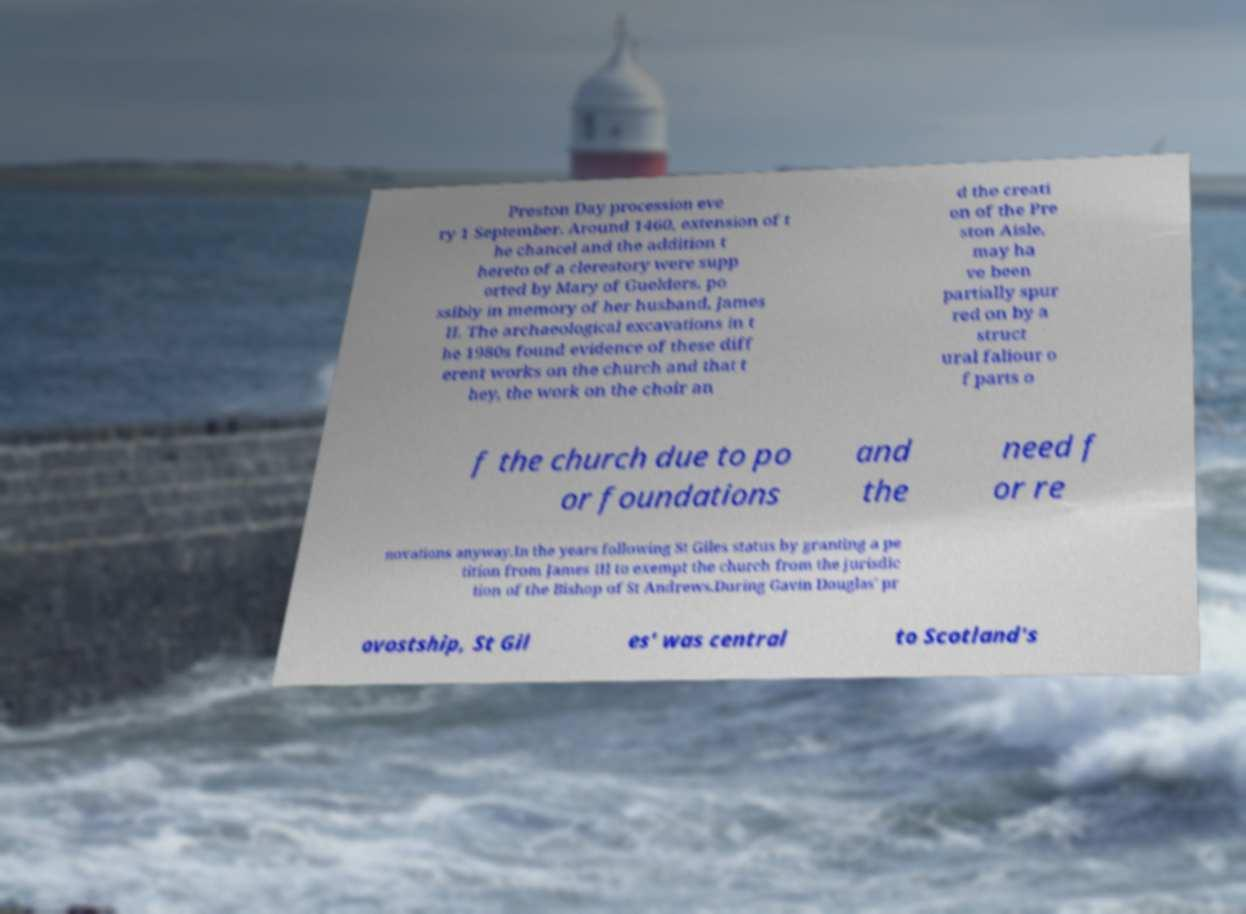There's text embedded in this image that I need extracted. Can you transcribe it verbatim? Preston Day procession eve ry 1 September. Around 1460, extension of t he chancel and the addition t hereto of a clerestory were supp orted by Mary of Guelders, po ssibly in memory of her husband, James II. The archaeological excavations in t he 1980s found evidence of these diff erent works on the church and that t hey, the work on the choir an d the creati on of the Pre ston Aisle, may ha ve been partially spur red on by a struct ural faliour o f parts o f the church due to po or foundations and the need f or re novations anyway.In the years following St Giles status by granting a pe tition from James III to exempt the church from the jurisdic tion of the Bishop of St Andrews.During Gavin Douglas' pr ovostship, St Gil es' was central to Scotland's 